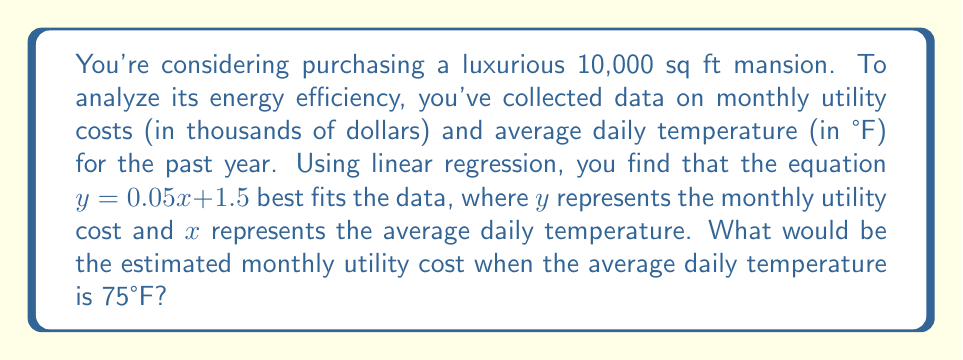Show me your answer to this math problem. To solve this problem, we'll use the linear regression equation provided and substitute the given temperature value:

1) The linear regression equation is:
   $y = 0.05x + 1.5$

   Where:
   $y$ = monthly utility cost (in thousands of dollars)
   $x$ = average daily temperature (in °F)

2) We need to find $y$ when $x = 75$:

   $y = 0.05(75) + 1.5$

3) Let's calculate step by step:
   $y = 3.75 + 1.5$
   $y = 5.25$

4) Remember, this result is in thousands of dollars. So, the actual cost is $5,250.

Therefore, when the average daily temperature is 75°F, the estimated monthly utility cost for the mansion would be $5,250.
Answer: $5,250 